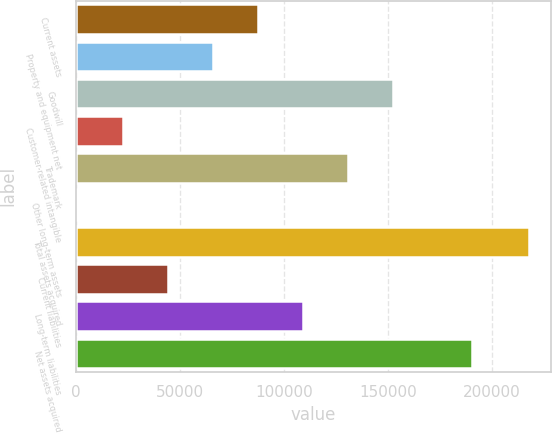<chart> <loc_0><loc_0><loc_500><loc_500><bar_chart><fcel>Current assets<fcel>Property and equipment net<fcel>Goodwill<fcel>Customer-related intangible<fcel>Trademark<fcel>Other long-term assets<fcel>Total assets acquired<fcel>Current liabilities<fcel>Long-term liabilities<fcel>Net assets acquired<nl><fcel>87476<fcel>65814<fcel>152462<fcel>22490<fcel>130800<fcel>828<fcel>217448<fcel>44152<fcel>109138<fcel>190465<nl></chart> 